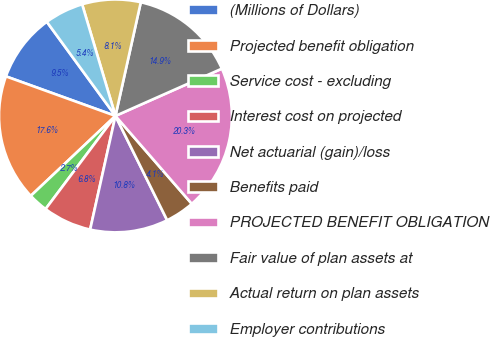<chart> <loc_0><loc_0><loc_500><loc_500><pie_chart><fcel>(Millions of Dollars)<fcel>Projected benefit obligation<fcel>Service cost - excluding<fcel>Interest cost on projected<fcel>Net actuarial (gain)/loss<fcel>Benefits paid<fcel>PROJECTED BENEFIT OBLIGATION<fcel>Fair value of plan assets at<fcel>Actual return on plan assets<fcel>Employer contributions<nl><fcel>9.46%<fcel>17.56%<fcel>2.71%<fcel>6.76%<fcel>10.81%<fcel>4.06%<fcel>20.27%<fcel>14.86%<fcel>8.11%<fcel>5.41%<nl></chart> 